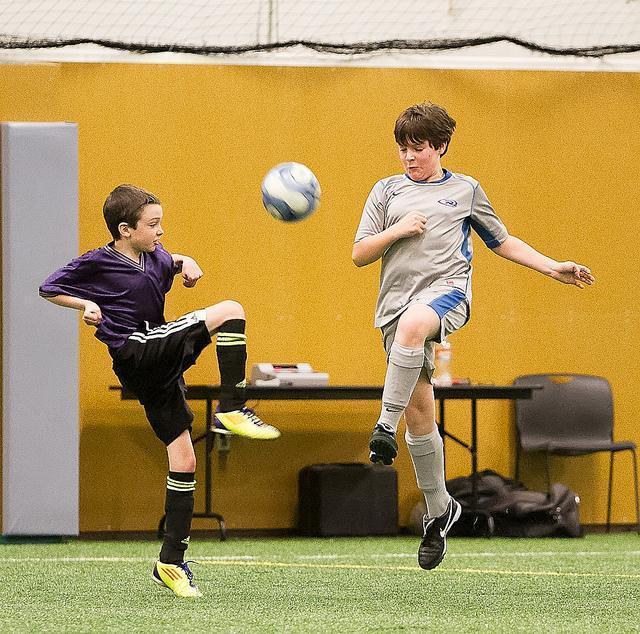How many people are visible?
Give a very brief answer. 2. 